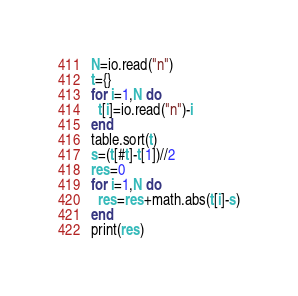Convert code to text. <code><loc_0><loc_0><loc_500><loc_500><_Lua_>N=io.read("n")
t={}
for i=1,N do
  t[i]=io.read("n")-i
end
table.sort(t)
s=(t[#t]-t[1])//2
res=0
for i=1,N do
  res=res+math.abs(t[i]-s)
end
print(res)</code> 